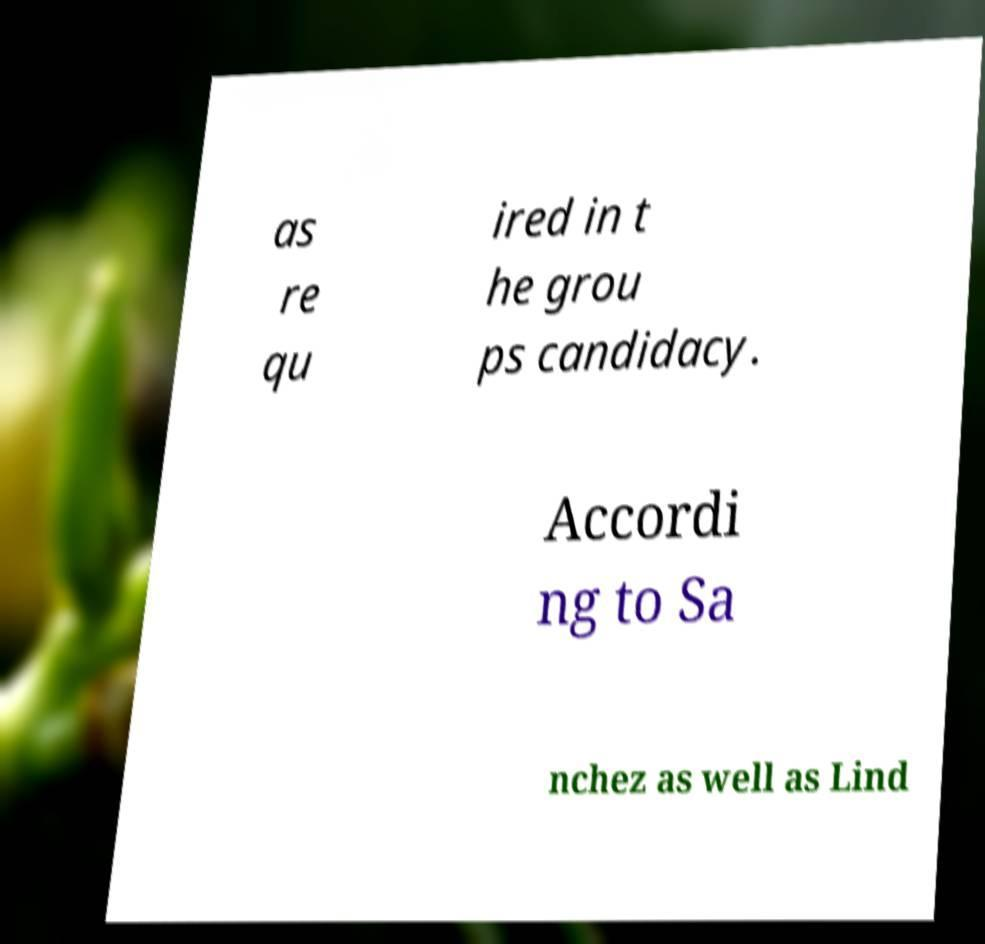Could you assist in decoding the text presented in this image and type it out clearly? as re qu ired in t he grou ps candidacy. Accordi ng to Sa nchez as well as Lind 